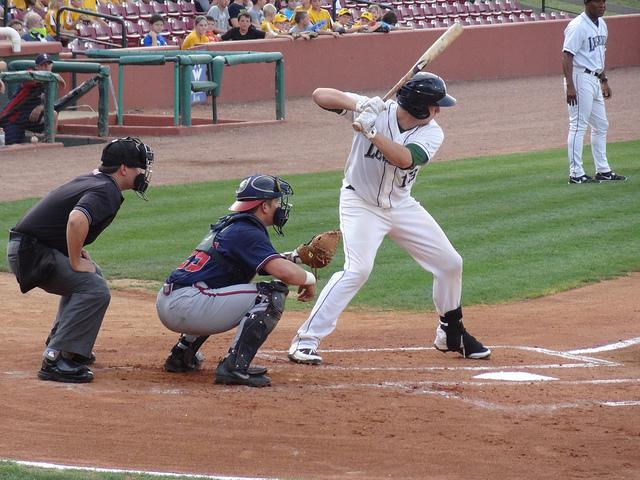Is there a suggested website on the picture?
Give a very brief answer. No. What is this sport?
Concise answer only. Baseball. Who is the player squatting behind batter?
Quick response, please. Catcher. How many balls?
Write a very short answer. 0. What color shirt is the umpire wearing?
Concise answer only. Black. What did batter just do?
Keep it brief. Swing. 